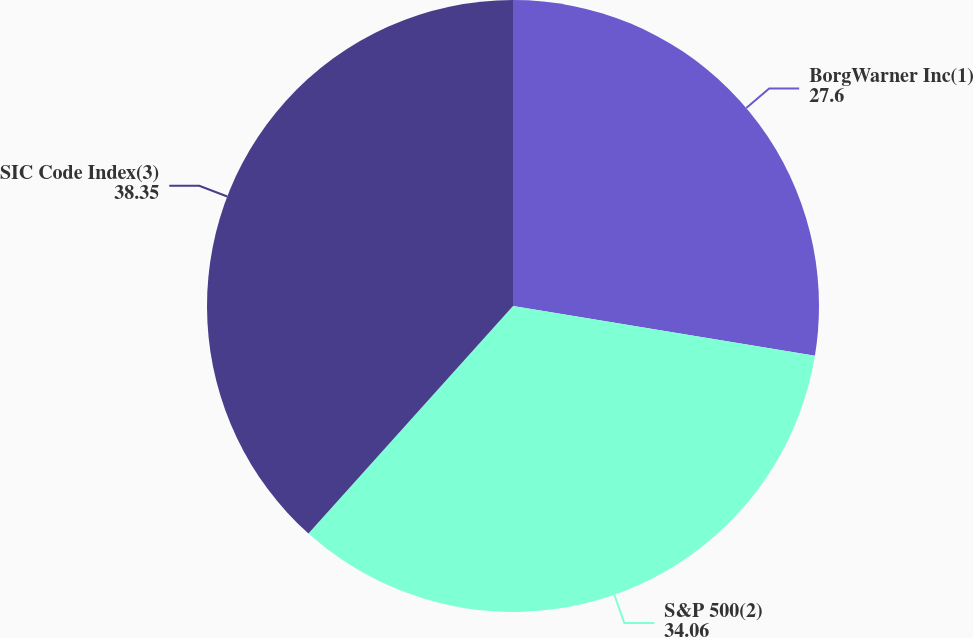Convert chart to OTSL. <chart><loc_0><loc_0><loc_500><loc_500><pie_chart><fcel>BorgWarner Inc(1)<fcel>S&P 500(2)<fcel>SIC Code Index(3)<nl><fcel>27.6%<fcel>34.06%<fcel>38.35%<nl></chart> 